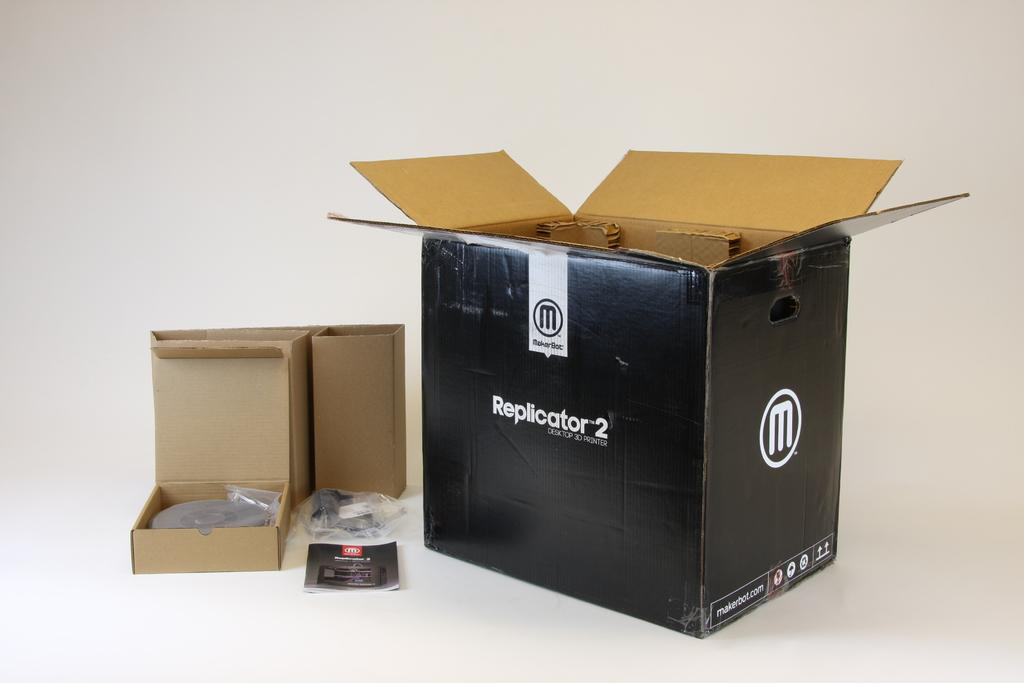<image>
Summarize the visual content of the image. A 3d printer called the Replicator 2 made by MarkerBot. 